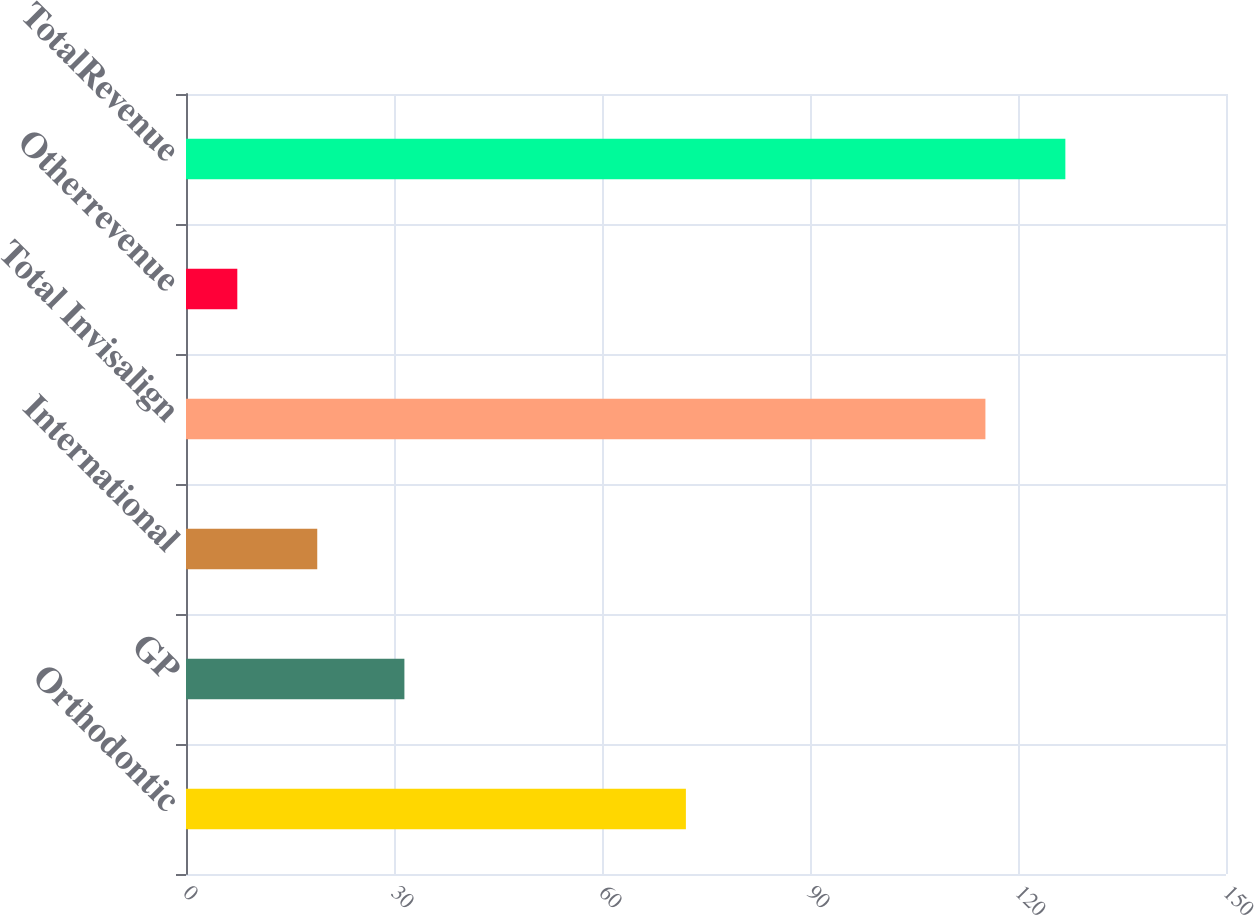<chart> <loc_0><loc_0><loc_500><loc_500><bar_chart><fcel>Orthodontic<fcel>GP<fcel>International<fcel>Total Invisalign<fcel>Otherrevenue<fcel>TotalRevenue<nl><fcel>72.1<fcel>31.5<fcel>18.93<fcel>115.3<fcel>7.4<fcel>126.83<nl></chart> 